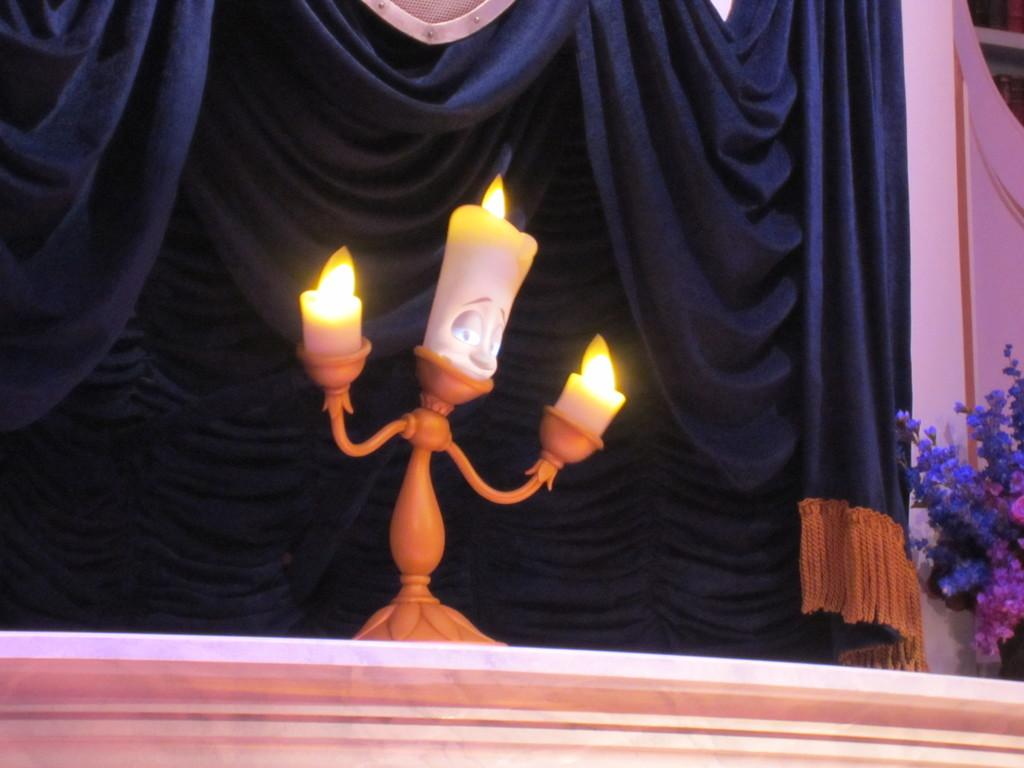What objects are on the stand in the image? There are three candles on a single stand in the image. What can be seen in the background of the image? There is a curtain in the background of the image. What is located beside the curtain in the background? There is a flower plant beside the curtain in the background. What type of coal is being used to fuel the candles in the image? There is no coal present in the image; the candles are likely fueled by wax. 